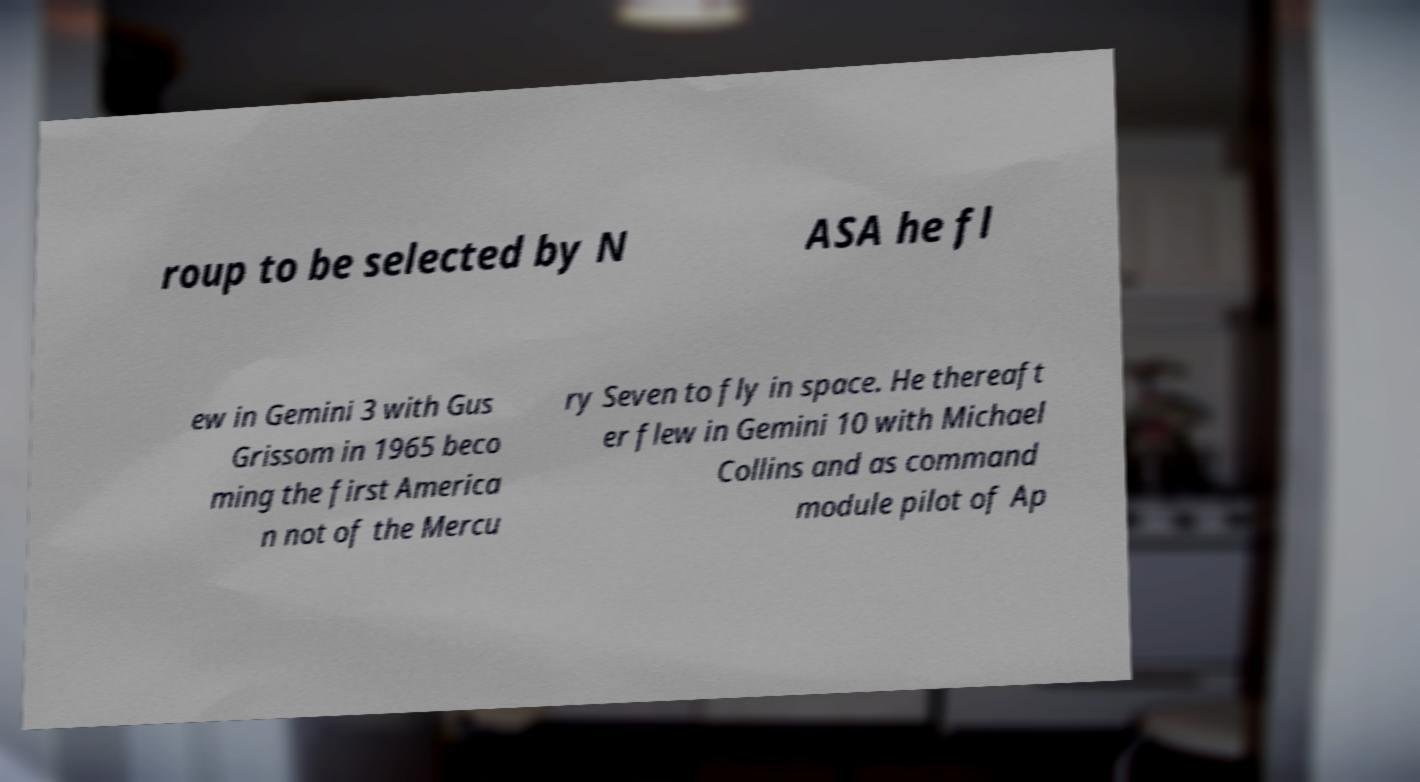There's text embedded in this image that I need extracted. Can you transcribe it verbatim? roup to be selected by N ASA he fl ew in Gemini 3 with Gus Grissom in 1965 beco ming the first America n not of the Mercu ry Seven to fly in space. He thereaft er flew in Gemini 10 with Michael Collins and as command module pilot of Ap 